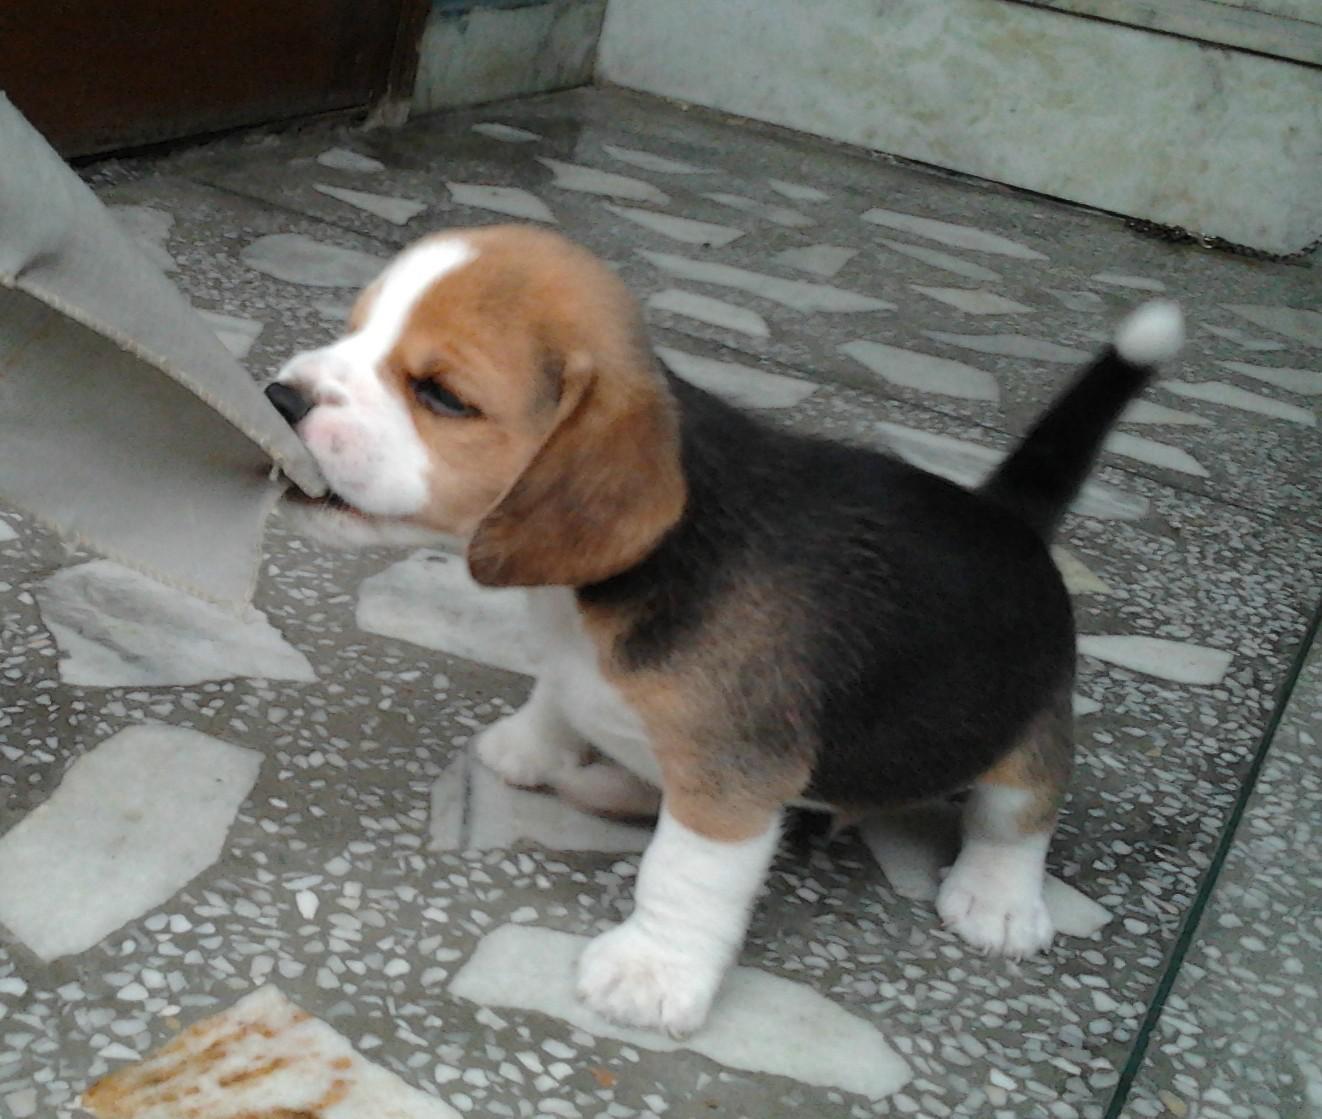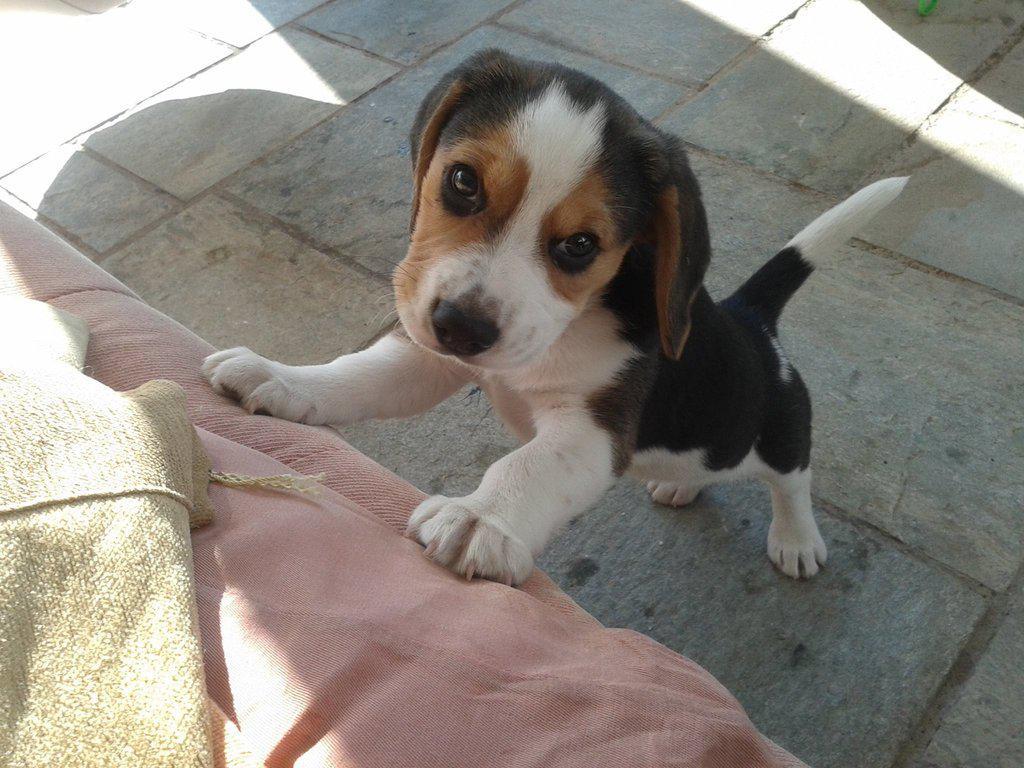The first image is the image on the left, the second image is the image on the right. For the images shown, is this caption "One dog is chewing on something." true? Answer yes or no. Yes. The first image is the image on the left, the second image is the image on the right. For the images shown, is this caption "Each image shows one young beagle, and no beagle is in a reclining pose." true? Answer yes or no. Yes. 